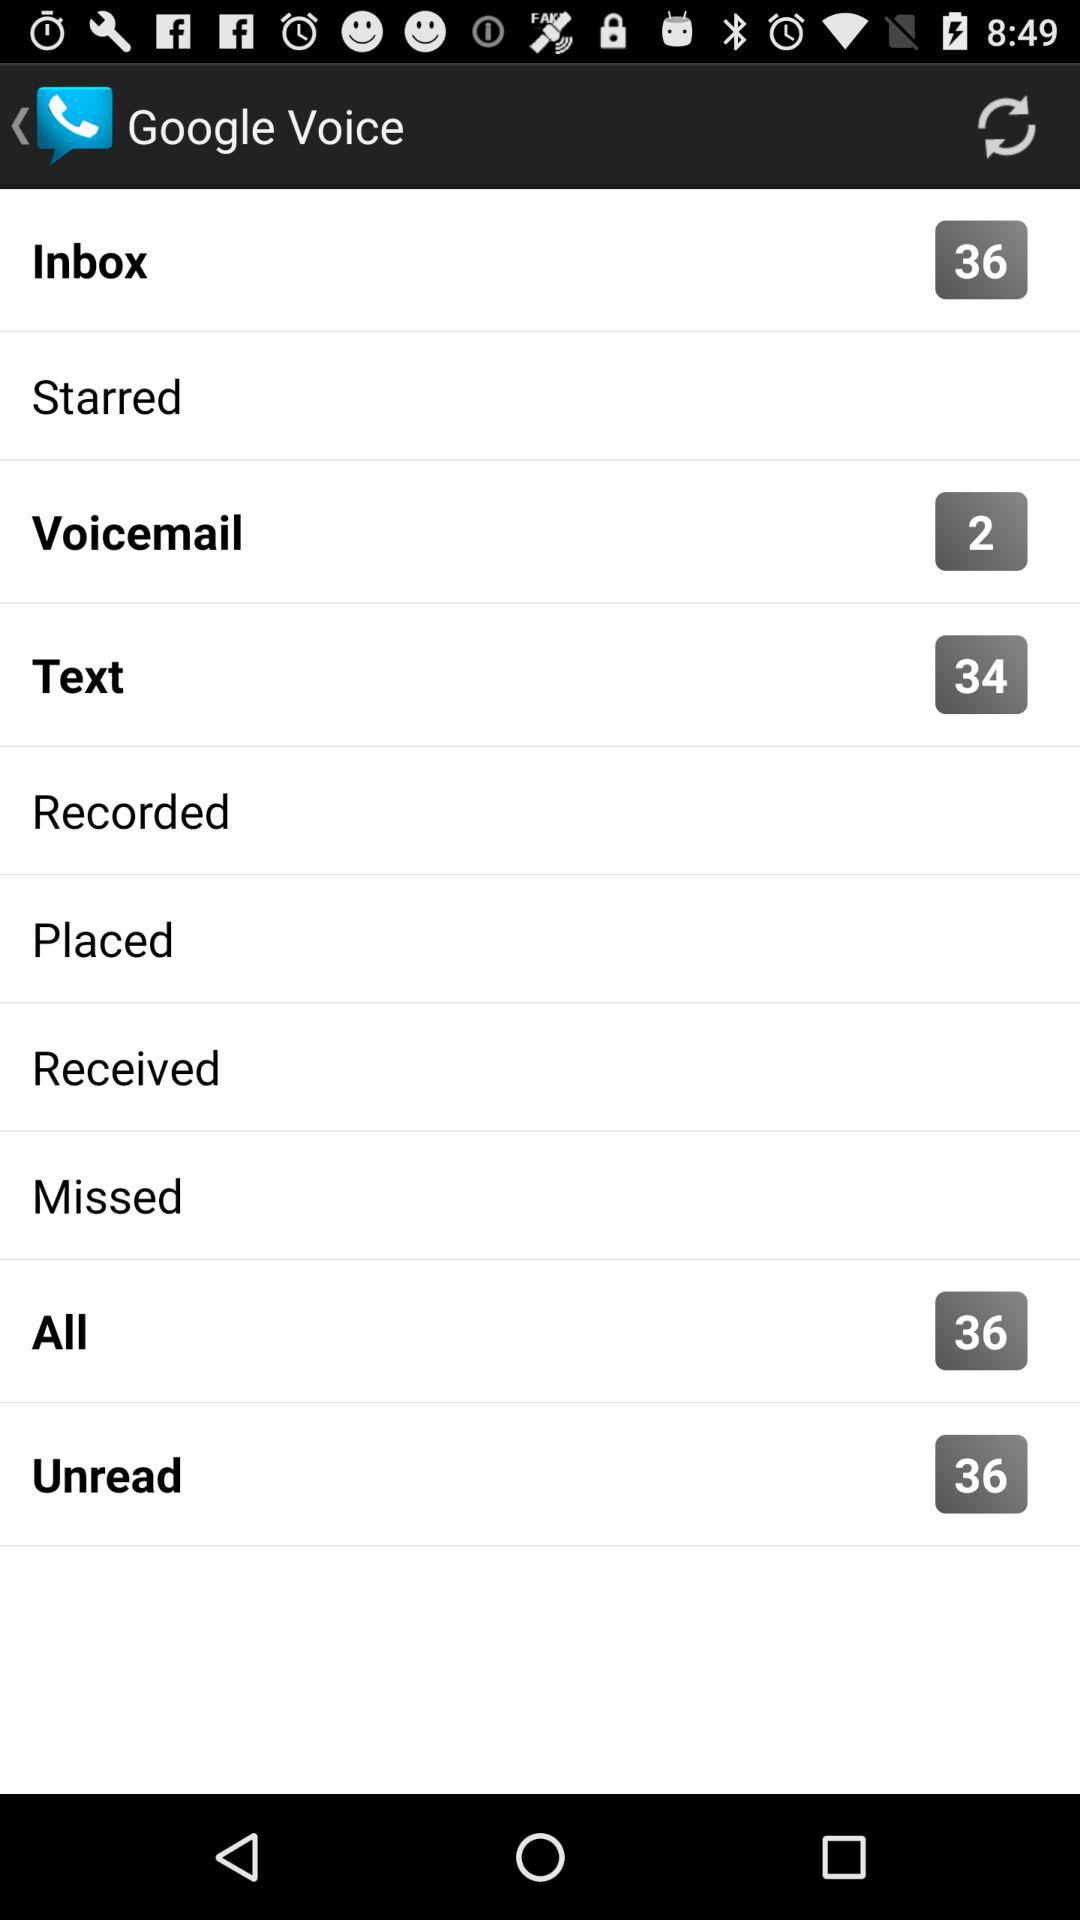What is the application name? The application name is "Google Voice". 